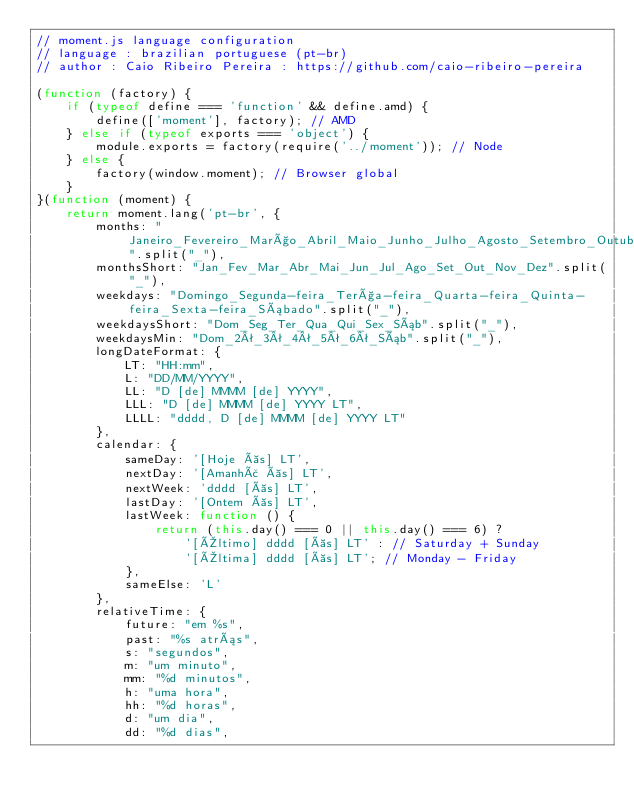Convert code to text. <code><loc_0><loc_0><loc_500><loc_500><_JavaScript_>// moment.js language configuration
// language : brazilian portuguese (pt-br)
// author : Caio Ribeiro Pereira : https://github.com/caio-ribeiro-pereira

(function (factory) {
    if (typeof define === 'function' && define.amd) {
        define(['moment'], factory); // AMD
    } else if (typeof exports === 'object') {
        module.exports = factory(require('../moment')); // Node
    } else {
        factory(window.moment); // Browser global
    }
}(function (moment) {
    return moment.lang('pt-br', {
        months: "Janeiro_Fevereiro_Março_Abril_Maio_Junho_Julho_Agosto_Setembro_Outubro_Novembro_Dezembro".split("_"),
        monthsShort: "Jan_Fev_Mar_Abr_Mai_Jun_Jul_Ago_Set_Out_Nov_Dez".split("_"),
        weekdays: "Domingo_Segunda-feira_Terça-feira_Quarta-feira_Quinta-feira_Sexta-feira_Sábado".split("_"),
        weekdaysShort: "Dom_Seg_Ter_Qua_Qui_Sex_Sáb".split("_"),
        weekdaysMin: "Dom_2ª_3ª_4ª_5ª_6ª_Sáb".split("_"),
        longDateFormat: {
            LT: "HH:mm",
            L: "DD/MM/YYYY",
            LL: "D [de] MMMM [de] YYYY",
            LLL: "D [de] MMMM [de] YYYY LT",
            LLLL: "dddd, D [de] MMMM [de] YYYY LT"
        },
        calendar: {
            sameDay: '[Hoje às] LT',
            nextDay: '[Amanhã às] LT',
            nextWeek: 'dddd [às] LT',
            lastDay: '[Ontem às] LT',
            lastWeek: function () {
                return (this.day() === 0 || this.day() === 6) ?
                    '[Último] dddd [às] LT' : // Saturday + Sunday
                    '[Última] dddd [às] LT'; // Monday - Friday
            },
            sameElse: 'L'
        },
        relativeTime: {
            future: "em %s",
            past: "%s atrás",
            s: "segundos",
            m: "um minuto",
            mm: "%d minutos",
            h: "uma hora",
            hh: "%d horas",
            d: "um dia",
            dd: "%d dias",</code> 